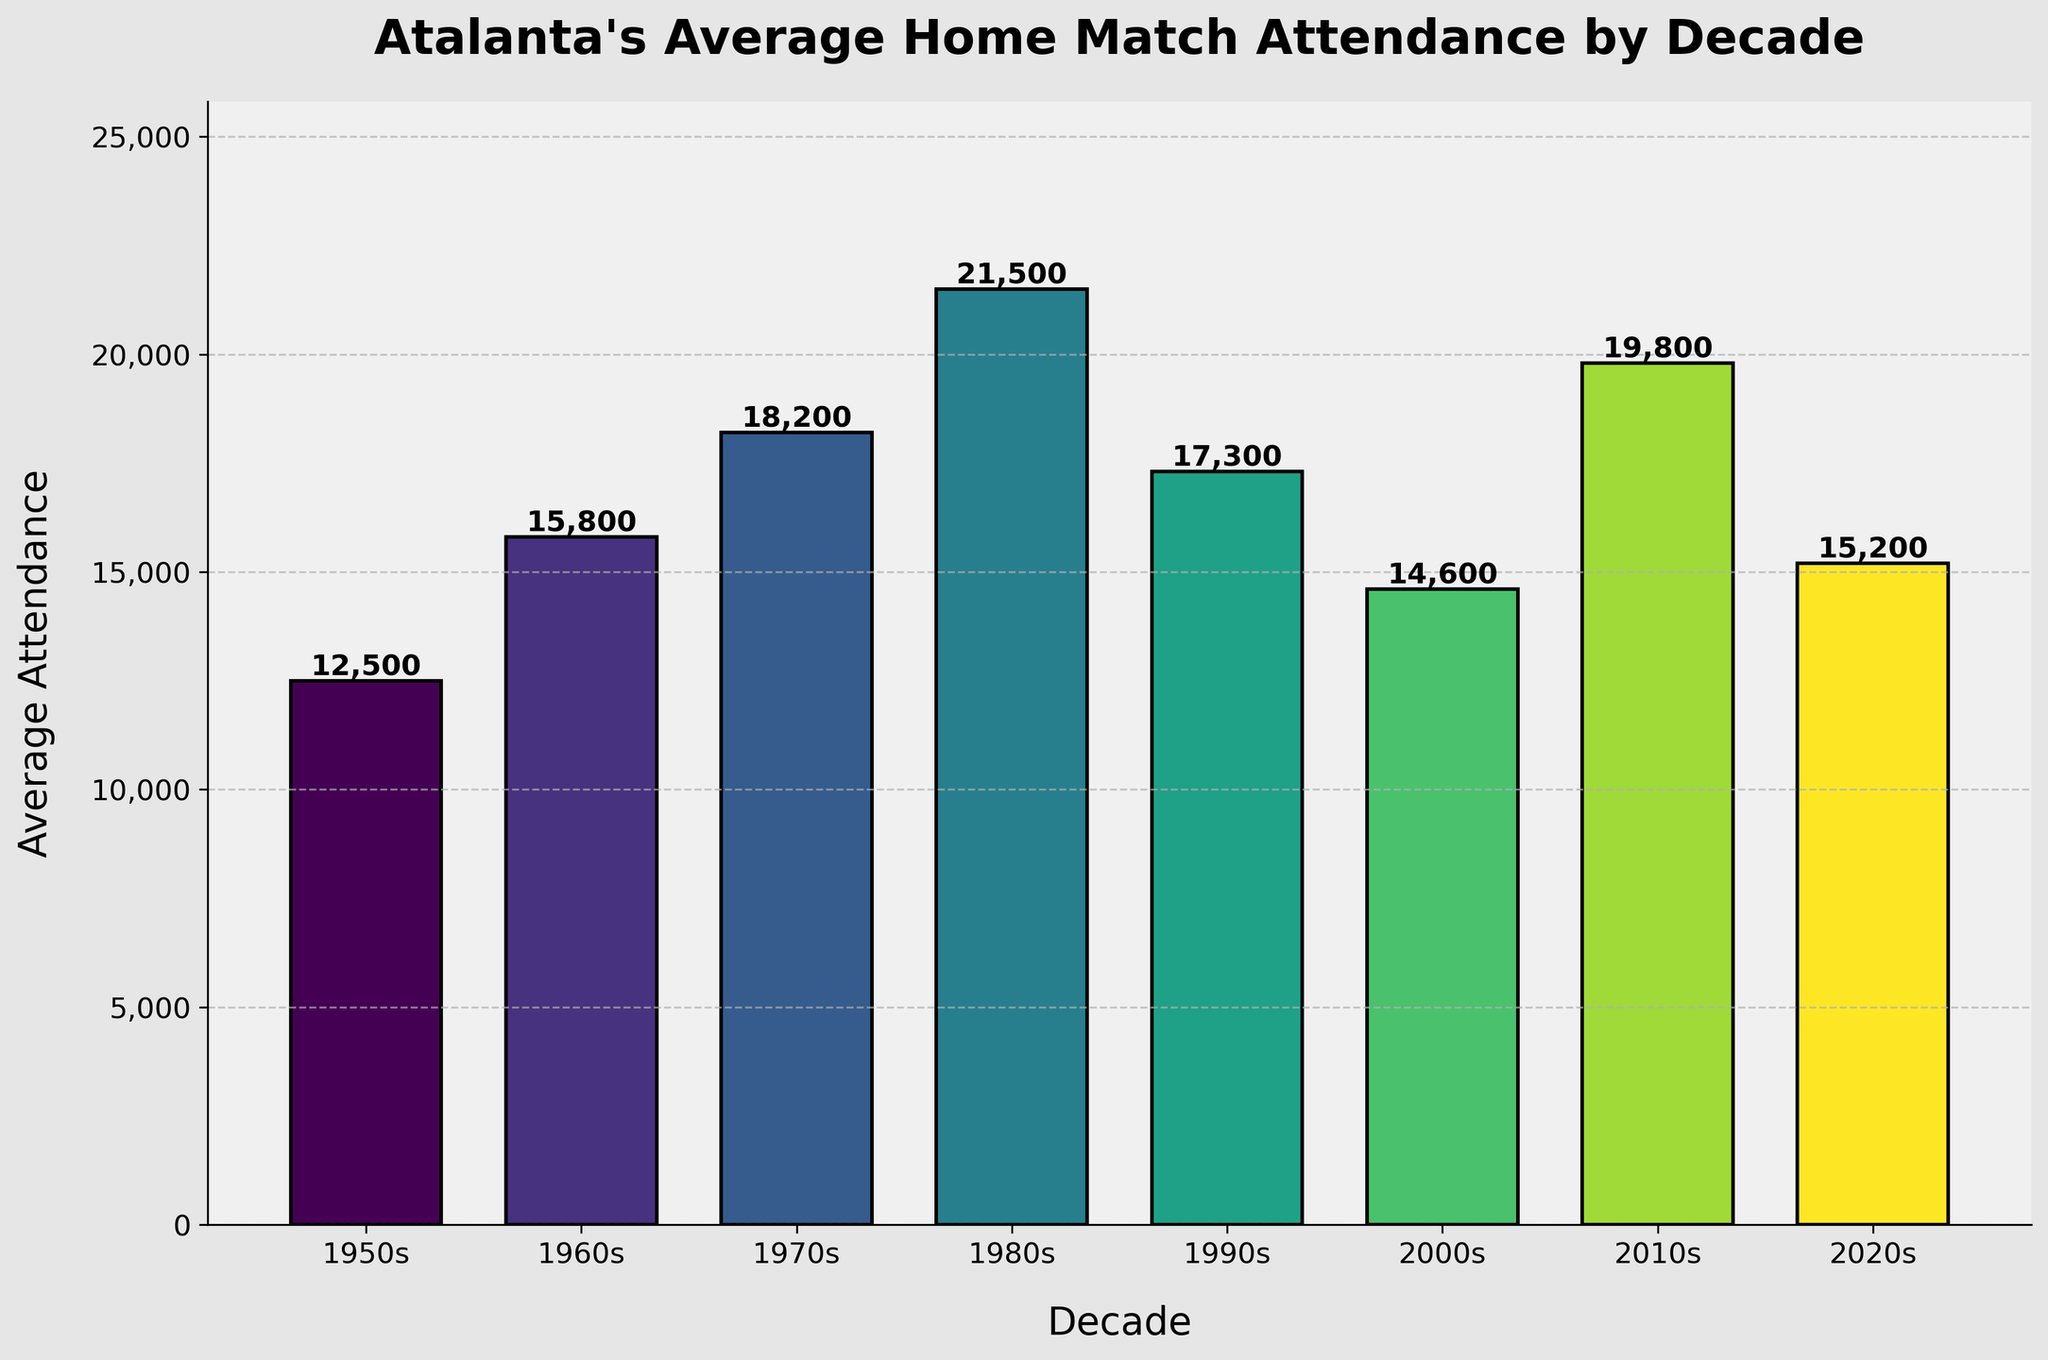What decade had the highest average attendance for Atalanta's home matches? The highest average attendance can be identified by locating the tallest bar in the bar chart. The tallest bar corresponds to the 1980s.
Answer: 1980s How much higher was the attendance in the 1980s compared to the 1990s? To find this, subtract the average attendance of the 1990s from the 1980s: 21500 (1980s) - 17300 (1990s) = 4200.
Answer: 4200 Identify the decade with the lowest average attendance. The lowest average attendance can be identified by locating the shortest bar in the bar chart. The shortest bar corresponds to the 1950s.
Answer: 1950s What is the difference in average attendance between the 2010s and the 2020s? To find this, subtract the average attendance of the 2020s from the 2010s: 19800 (2010s) - 15200 (2020s) = 4600.
Answer: 4600 Was the average attendance in the 2000s higher or lower than in the 1960s? Compare the lengths of the bars for the 2000s and the 1960s. The bar for the 2000s is shorter than the bar for the 1960s, indicating it is lower.
Answer: Lower What is the total average attendance over the decades of the 1950s, 1960s, and 1970s combined? Sum the average attendances of the 1950s, 1960s, and 1970s: 12500 (1950s) + 15800 (1960s) + 18200 (1970s) = 46500.
Answer: 46500 Did average attendance rise or fall from the 1950s to the 1960s? Compare the lengths of the bars for the 1950s and the 1960s. The bar for the 1960s is taller, indicating a rise in attendance.
Answer: Rise Which decade experienced a greater change in average attendance: between the 1960s and 1970s or between the 2000s and 2010s? Calculate the differences: 1970s - 1960s = 2400, 2010s - 2000s = 5200. The greater change occurred between the 2000s and 2010s.
Answer: 2000s to 2010s How does the 2020s average attendance compare visually to the 1960s average attendance in terms of bar height? Compare the bars for the 2020s and 1960s. The bar for the 2020s is shorter than the bar for the 1960s, indicating the 2020s attendance is lower.
Answer: Lower What is the visual trend in attendance from the 1950s to the 1980s? Observing the bar heights from the 1950s to the 1980s, the bars are getting progressively taller, indicating a rising trend in average attendance.
Answer: Rising 